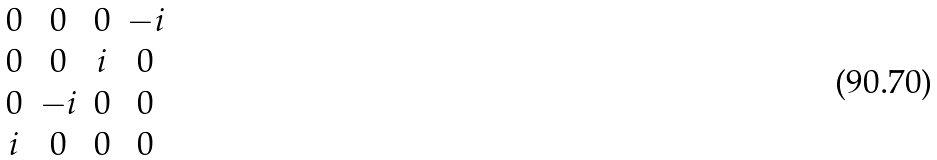<formula> <loc_0><loc_0><loc_500><loc_500>\begin{matrix} 0 & 0 & 0 & - i \\ 0 & 0 & i & 0 \\ 0 & - i & 0 & 0 \\ i & 0 & 0 & 0 \\ \end{matrix}</formula> 